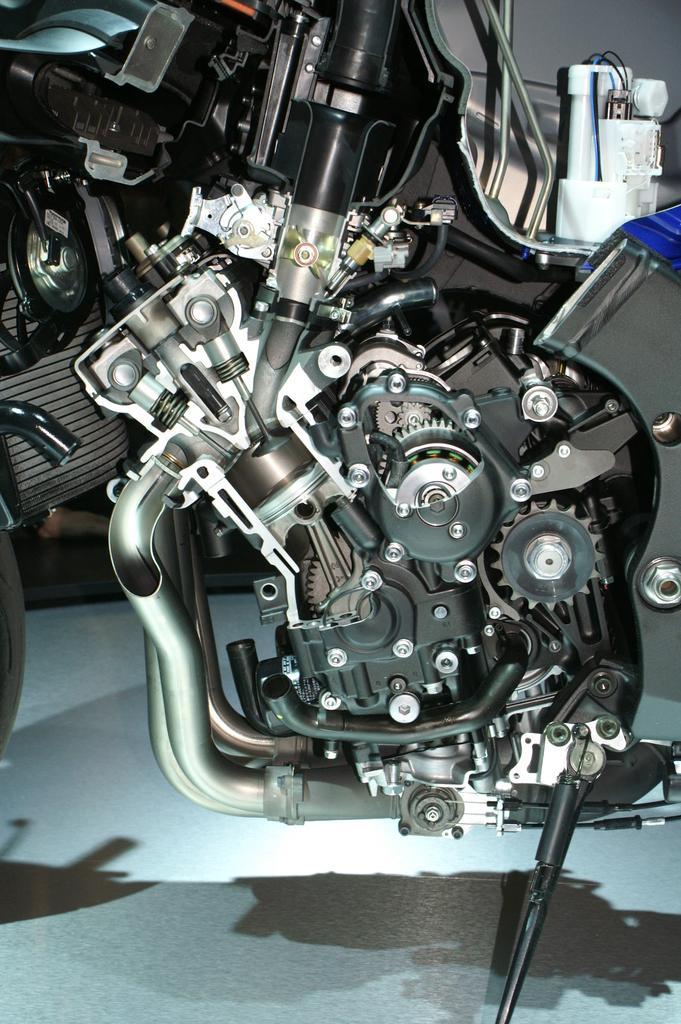Please provide a concise description of this image. This image consists of a motor of a bike. There is stand at the bottom. 